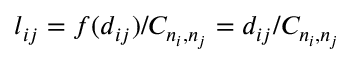Convert formula to latex. <formula><loc_0><loc_0><loc_500><loc_500>l _ { i j } = f ( d _ { i j } ) / C _ { n _ { i } , n _ { j } } = d _ { i j } / C _ { n _ { i } , n _ { j } }</formula> 